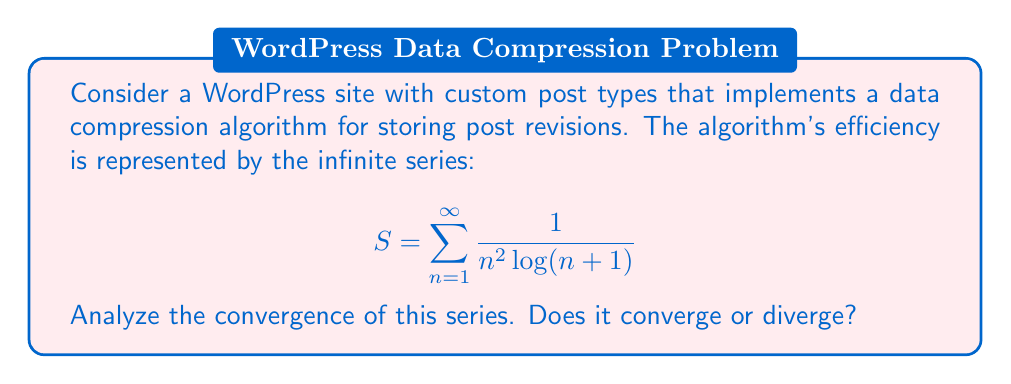Could you help me with this problem? To analyze the convergence of this series, we'll use the integral test and comparison test:

1) First, let's define $f(x) = \frac{1}{x^2 \log(x+1)}$ for $x \geq 1$.

2) We need to check if $\int_1^{\infty} f(x) dx$ converges:

   $$\int_1^{\infty} \frac{1}{x^2 \log(x+1)} dx$$

3) Let $u = \log(x+1)$, then $du = \frac{1}{x+1}dx$ and $x = e^u - 1$:

   $$\int_{\log 2}^{\infty} \frac{1}{(e^u - 1)^2 u} \cdot (e^u - 1) du = \int_{\log 2}^{\infty} \frac{1}{(e^u - 1)u} du$$

4) For large $u$, $e^u - 1 \approx e^u$, so we can compare with:

   $$\int_{\log 2}^{\infty} \frac{1}{e^u u} du$$

5) This integral converges because:

   $$\int_{\log 2}^{\infty} \frac{1}{e^u u} du < \int_{\log 2}^{\infty} \frac{1}{u^2} du = -\frac{1}{u}\bigg|_{\log 2}^{\infty} = \frac{1}{\log 2}$$

6) By the comparison test, our original integral also converges.

7) Therefore, by the integral test, the series $S = \sum_{n=1}^{\infty} \frac{1}{n^2 \log(n+1)}$ converges.
Answer: The series converges. 